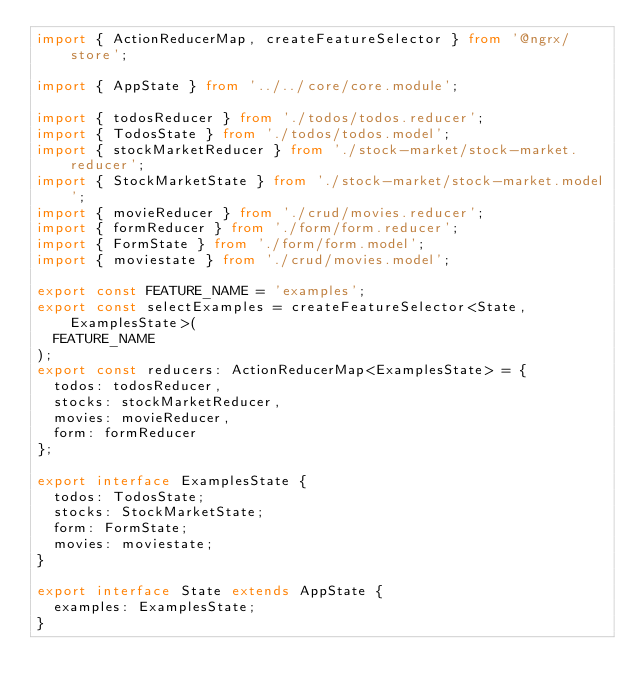Convert code to text. <code><loc_0><loc_0><loc_500><loc_500><_TypeScript_>import { ActionReducerMap, createFeatureSelector } from '@ngrx/store';

import { AppState } from '../../core/core.module';

import { todosReducer } from './todos/todos.reducer';
import { TodosState } from './todos/todos.model';
import { stockMarketReducer } from './stock-market/stock-market.reducer';
import { StockMarketState } from './stock-market/stock-market.model';
import { movieReducer } from './crud/movies.reducer';
import { formReducer } from './form/form.reducer';
import { FormState } from './form/form.model';
import { moviestate } from './crud/movies.model';

export const FEATURE_NAME = 'examples';
export const selectExamples = createFeatureSelector<State, ExamplesState>(
  FEATURE_NAME
);
export const reducers: ActionReducerMap<ExamplesState> = {
  todos: todosReducer,
  stocks: stockMarketReducer,
  movies: movieReducer,
  form: formReducer
};

export interface ExamplesState {
  todos: TodosState;
  stocks: StockMarketState;
  form: FormState;
  movies: moviestate;
}

export interface State extends AppState {
  examples: ExamplesState;
}
</code> 